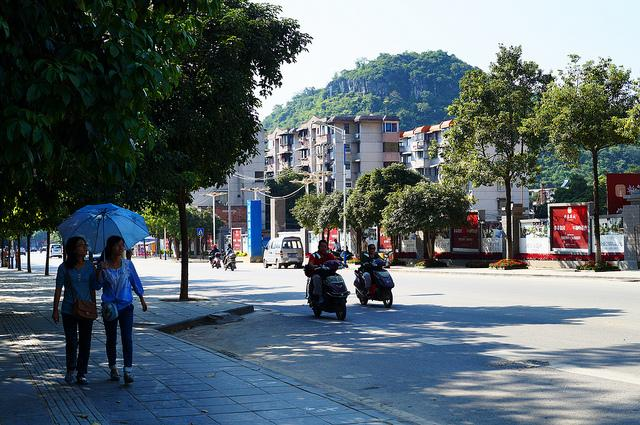What protection does an umbrella offer here?

Choices:
A) locusts
B) nuclear fallout
C) rain
D) sun shade sun shade 